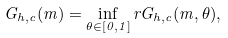Convert formula to latex. <formula><loc_0><loc_0><loc_500><loc_500>G _ { h , c } ( m ) = \inf _ { \theta \in [ 0 , 1 ] } r G _ { h , c } ( m , \theta ) ,</formula> 